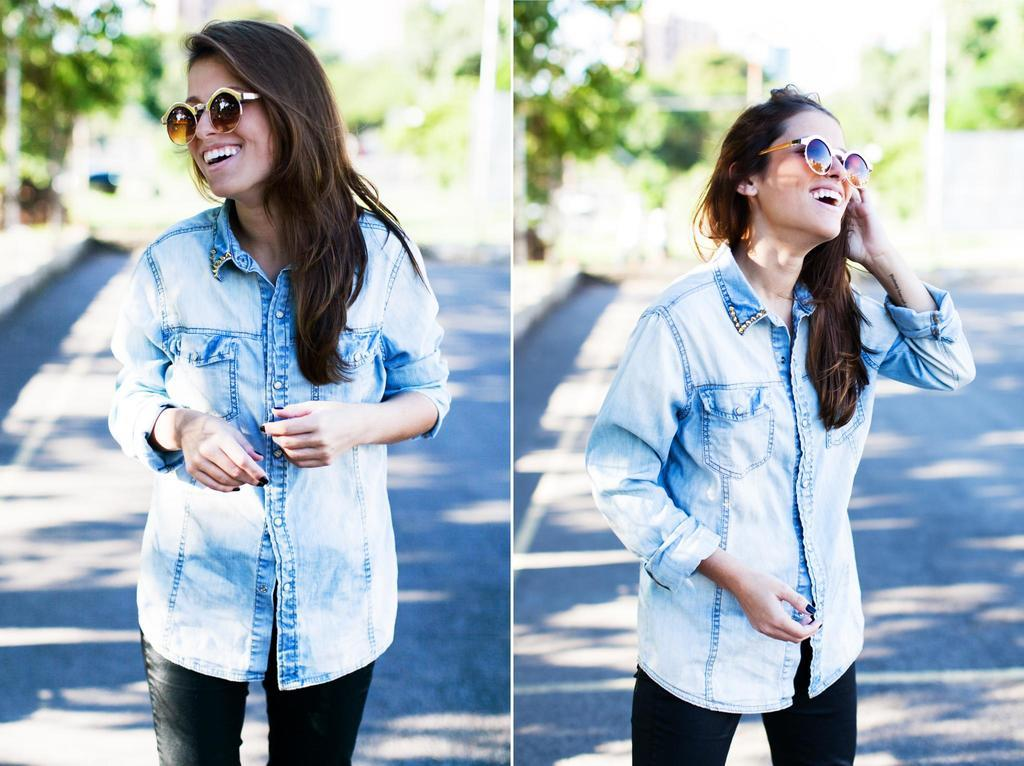Who is present in the image? There is a woman in the image. What is the woman wearing on her face? The woman is wearing goggles. Where is the woman standing? The woman is standing on a path. What expression does the woman have? The woman is smiling. How would you describe the background of the image? The background of the image is blurry. What type of slip is the woman wearing on her feet in the image? There is no mention of the woman wearing a slip in the image; she is standing on a path. How many cows can be seen grazing in the background of the image? There are no cows present in the image; the background is blurry. 